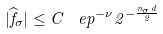Convert formula to latex. <formula><loc_0><loc_0><loc_500><loc_500>| \widehat { f } _ { \sigma } | \leq C \, \ e p ^ { - \nu } 2 ^ { - \frac { n _ { \sigma } d } { 2 } }</formula> 